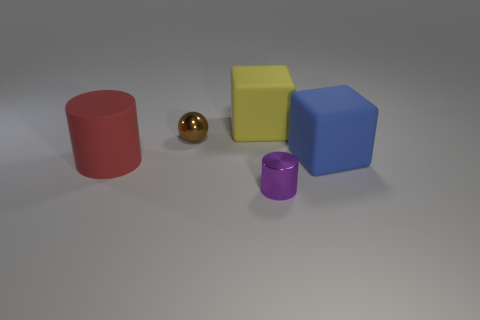Add 2 big red cylinders. How many objects exist? 7 Subtract all cylinders. How many objects are left? 3 Subtract 1 cubes. How many cubes are left? 1 Subtract all cyan blocks. Subtract all green cylinders. How many blocks are left? 2 Add 5 tiny objects. How many tiny objects are left? 7 Add 4 red rubber balls. How many red rubber balls exist? 4 Subtract 0 cyan balls. How many objects are left? 5 Subtract all tiny yellow metal cubes. Subtract all brown metallic balls. How many objects are left? 4 